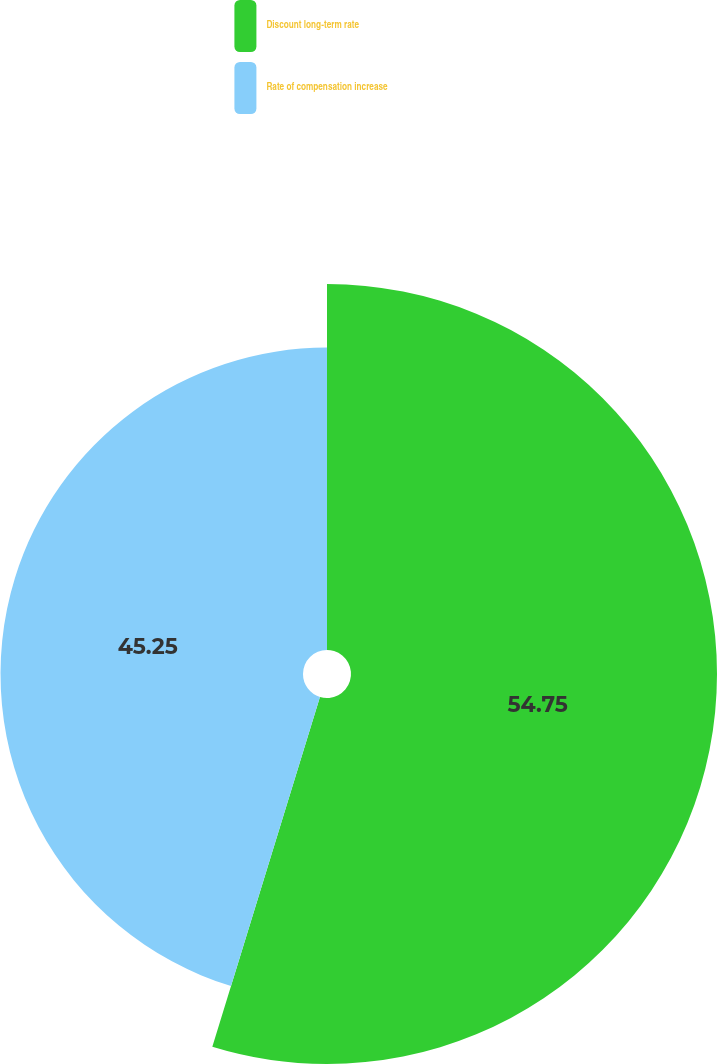<chart> <loc_0><loc_0><loc_500><loc_500><pie_chart><fcel>Discount long-term rate<fcel>Rate of compensation increase<nl><fcel>54.75%<fcel>45.25%<nl></chart> 